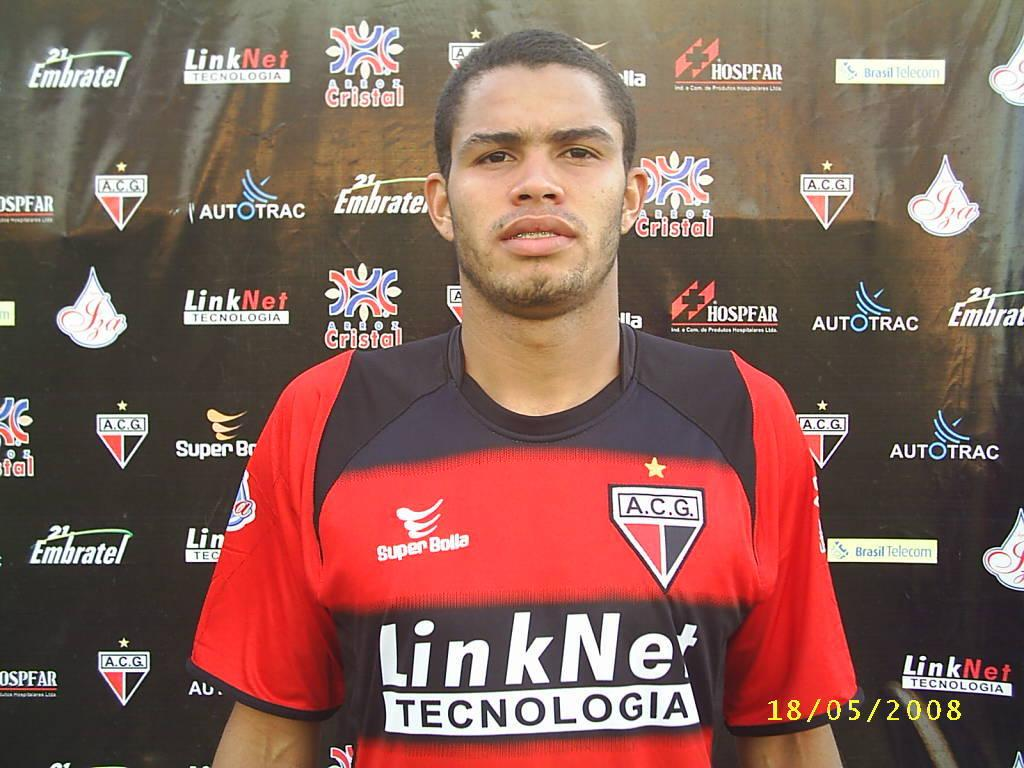<image>
Present a compact description of the photo's key features. A man has a jersey on with a Super Bolla logo on it. 